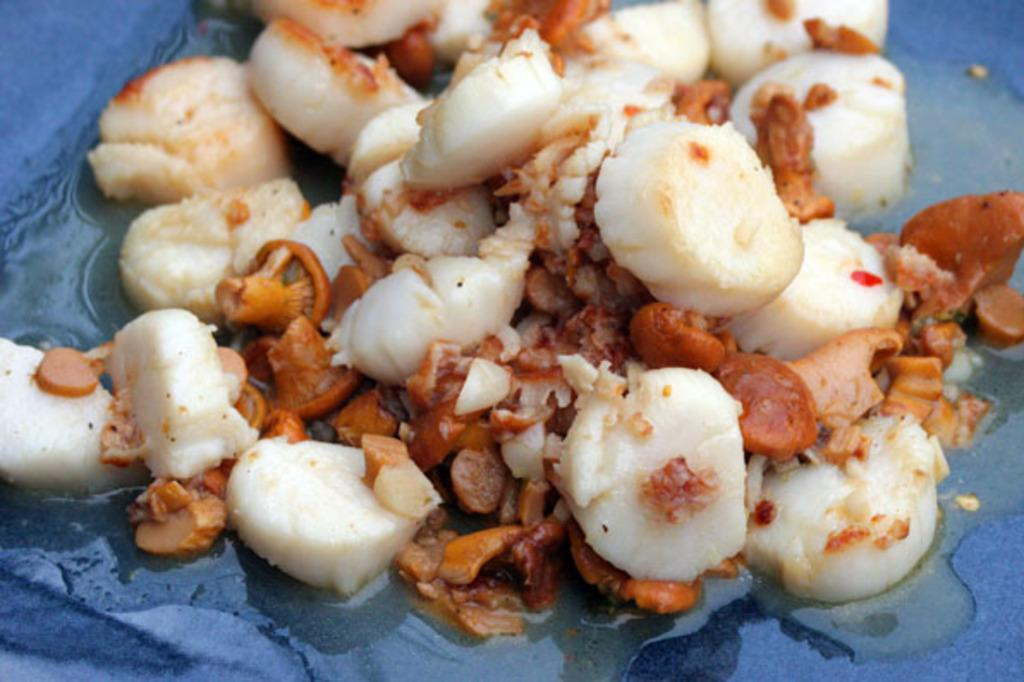What is present on the plate in the image? There is food in a plate in the image. What type of suit can be seen hanging in the background of the image? There is no suit present in the image; it only features food on a plate. What type of club is visible in the image? There is no club present in the image; it only features food on a plate. 